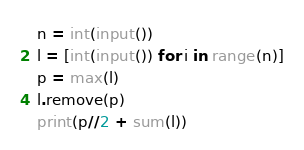Convert code to text. <code><loc_0><loc_0><loc_500><loc_500><_Python_>n = int(input())
l = [int(input()) for i in range(n)]
p = max(l)
l.remove(p)
print(p//2 + sum(l))</code> 